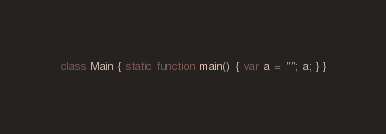<code> <loc_0><loc_0><loc_500><loc_500><_Haxe_>class Main { static function main() { var a = ""; a; } }</code> 